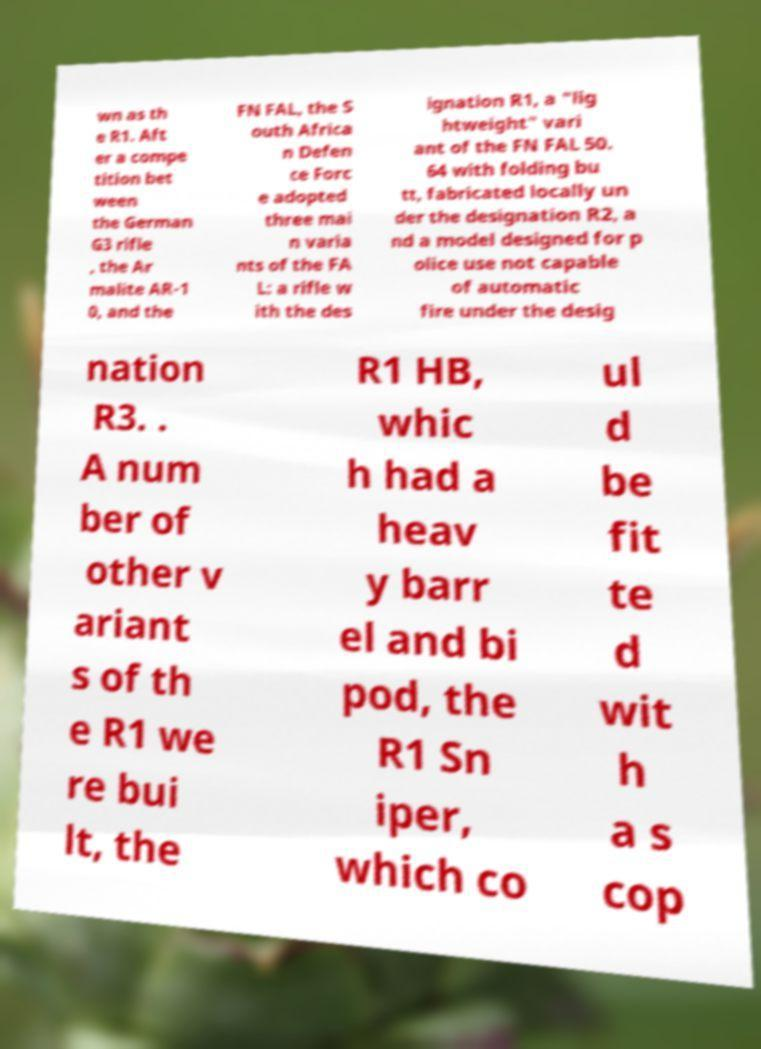Could you assist in decoding the text presented in this image and type it out clearly? wn as th e R1. Aft er a compe tition bet ween the German G3 rifle , the Ar malite AR-1 0, and the FN FAL, the S outh Africa n Defen ce Forc e adopted three mai n varia nts of the FA L: a rifle w ith the des ignation R1, a "lig htweight" vari ant of the FN FAL 50. 64 with folding bu tt, fabricated locally un der the designation R2, a nd a model designed for p olice use not capable of automatic fire under the desig nation R3. . A num ber of other v ariant s of th e R1 we re bui lt, the R1 HB, whic h had a heav y barr el and bi pod, the R1 Sn iper, which co ul d be fit te d wit h a s cop 